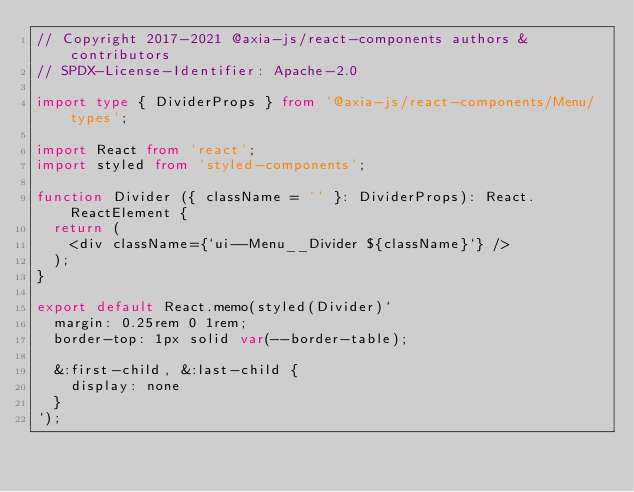Convert code to text. <code><loc_0><loc_0><loc_500><loc_500><_TypeScript_>// Copyright 2017-2021 @axia-js/react-components authors & contributors
// SPDX-License-Identifier: Apache-2.0

import type { DividerProps } from '@axia-js/react-components/Menu/types';

import React from 'react';
import styled from 'styled-components';

function Divider ({ className = '' }: DividerProps): React.ReactElement {
  return (
    <div className={`ui--Menu__Divider ${className}`} />
  );
}

export default React.memo(styled(Divider)`
  margin: 0.25rem 0 1rem;
  border-top: 1px solid var(--border-table);

  &:first-child, &:last-child {
    display: none
  }
`);
</code> 